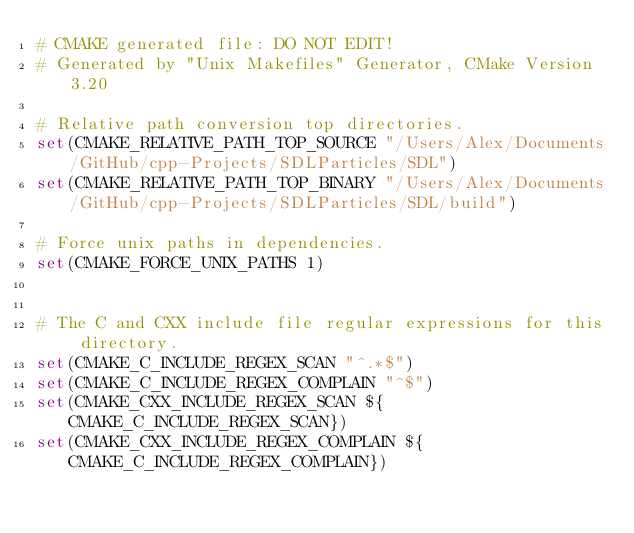<code> <loc_0><loc_0><loc_500><loc_500><_CMake_># CMAKE generated file: DO NOT EDIT!
# Generated by "Unix Makefiles" Generator, CMake Version 3.20

# Relative path conversion top directories.
set(CMAKE_RELATIVE_PATH_TOP_SOURCE "/Users/Alex/Documents/GitHub/cpp-Projects/SDLParticles/SDL")
set(CMAKE_RELATIVE_PATH_TOP_BINARY "/Users/Alex/Documents/GitHub/cpp-Projects/SDLParticles/SDL/build")

# Force unix paths in dependencies.
set(CMAKE_FORCE_UNIX_PATHS 1)


# The C and CXX include file regular expressions for this directory.
set(CMAKE_C_INCLUDE_REGEX_SCAN "^.*$")
set(CMAKE_C_INCLUDE_REGEX_COMPLAIN "^$")
set(CMAKE_CXX_INCLUDE_REGEX_SCAN ${CMAKE_C_INCLUDE_REGEX_SCAN})
set(CMAKE_CXX_INCLUDE_REGEX_COMPLAIN ${CMAKE_C_INCLUDE_REGEX_COMPLAIN})
</code> 